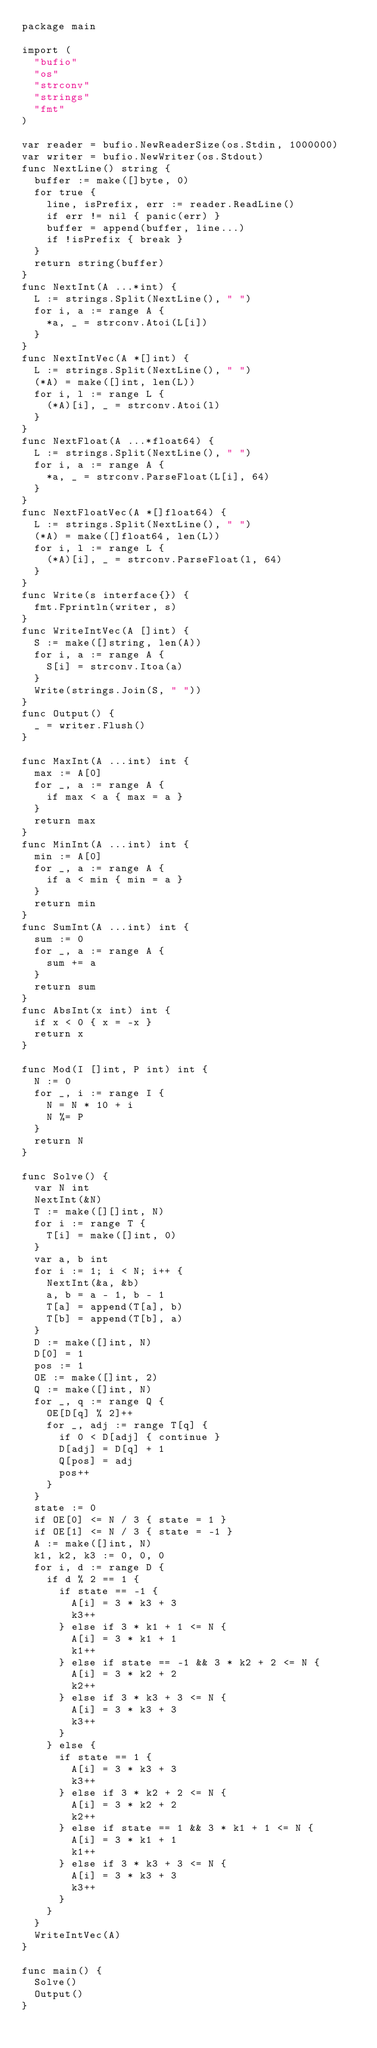Convert code to text. <code><loc_0><loc_0><loc_500><loc_500><_Go_>package main

import (
  "bufio"
  "os"
  "strconv"
  "strings"
  "fmt"
)

var reader = bufio.NewReaderSize(os.Stdin, 1000000)
var writer = bufio.NewWriter(os.Stdout)
func NextLine() string {
  buffer := make([]byte, 0)
  for true {
    line, isPrefix, err := reader.ReadLine()
    if err != nil { panic(err) }
    buffer = append(buffer, line...)
    if !isPrefix { break }
  }
  return string(buffer)
}
func NextInt(A ...*int) {
  L := strings.Split(NextLine(), " ")
  for i, a := range A {
    *a, _ = strconv.Atoi(L[i])
  }
}
func NextIntVec(A *[]int) {
  L := strings.Split(NextLine(), " ")
  (*A) = make([]int, len(L))
  for i, l := range L {
    (*A)[i], _ = strconv.Atoi(l)
  }
}
func NextFloat(A ...*float64) {
  L := strings.Split(NextLine(), " ")
  for i, a := range A {
    *a, _ = strconv.ParseFloat(L[i], 64)
  }
}
func NextFloatVec(A *[]float64) {
  L := strings.Split(NextLine(), " ")
  (*A) = make([]float64, len(L))
  for i, l := range L {
    (*A)[i], _ = strconv.ParseFloat(l, 64)
  }
}
func Write(s interface{}) {
  fmt.Fprintln(writer, s)
}
func WriteIntVec(A []int) {
  S := make([]string, len(A))
  for i, a := range A {
    S[i] = strconv.Itoa(a)
  }
  Write(strings.Join(S, " "))
}
func Output() {
  _ = writer.Flush()
}

func MaxInt(A ...int) int {
  max := A[0]
  for _, a := range A {
    if max < a { max = a }
  }
  return max
}
func MinInt(A ...int) int {
  min := A[0]
  for _, a := range A {
    if a < min { min = a }
  }
  return min
}
func SumInt(A ...int) int {
  sum := 0
  for _, a := range A {
    sum += a
  }
  return sum
}
func AbsInt(x int) int {
  if x < 0 { x = -x }
  return x
}

func Mod(I []int, P int) int {
  N := 0
  for _, i := range I {
    N = N * 10 + i
    N %= P
  }
  return N
}

func Solve() {
  var N int
  NextInt(&N)
  T := make([][]int, N)
  for i := range T {
    T[i] = make([]int, 0)
  }
  var a, b int
  for i := 1; i < N; i++ {
    NextInt(&a, &b)
    a, b = a - 1, b - 1
    T[a] = append(T[a], b)
    T[b] = append(T[b], a)
  }
  D := make([]int, N)
  D[0] = 1
  pos := 1
  OE := make([]int, 2)
  Q := make([]int, N)
  for _, q := range Q {
    OE[D[q] % 2]++
    for _, adj := range T[q] {
      if 0 < D[adj] { continue }
      D[adj] = D[q] + 1
      Q[pos] = adj
      pos++
    }
  }
  state := 0
  if OE[0] <= N / 3 { state = 1 }
  if OE[1] <= N / 3 { state = -1 }
  A := make([]int, N)
  k1, k2, k3 := 0, 0, 0
  for i, d := range D {
    if d % 2 == 1 {
      if state == -1 {
        A[i] = 3 * k3 + 3
        k3++
      } else if 3 * k1 + 1 <= N {
        A[i] = 3 * k1 + 1
        k1++
      } else if state == -1 && 3 * k2 + 2 <= N {
        A[i] = 3 * k2 + 2
        k2++
      } else if 3 * k3 + 3 <= N {
        A[i] = 3 * k3 + 3
        k3++
      }
    } else {
      if state == 1 {
        A[i] = 3 * k3 + 3
        k3++
      } else if 3 * k2 + 2 <= N {
        A[i] = 3 * k2 + 2
        k2++
      } else if state == 1 && 3 * k1 + 1 <= N {
        A[i] = 3 * k1 + 1
        k1++
      } else if 3 * k3 + 3 <= N {
        A[i] = 3 * k3 + 3
        k3++
      }
    }
  }
  WriteIntVec(A)
}

func main() {
  Solve()
  Output()
}</code> 